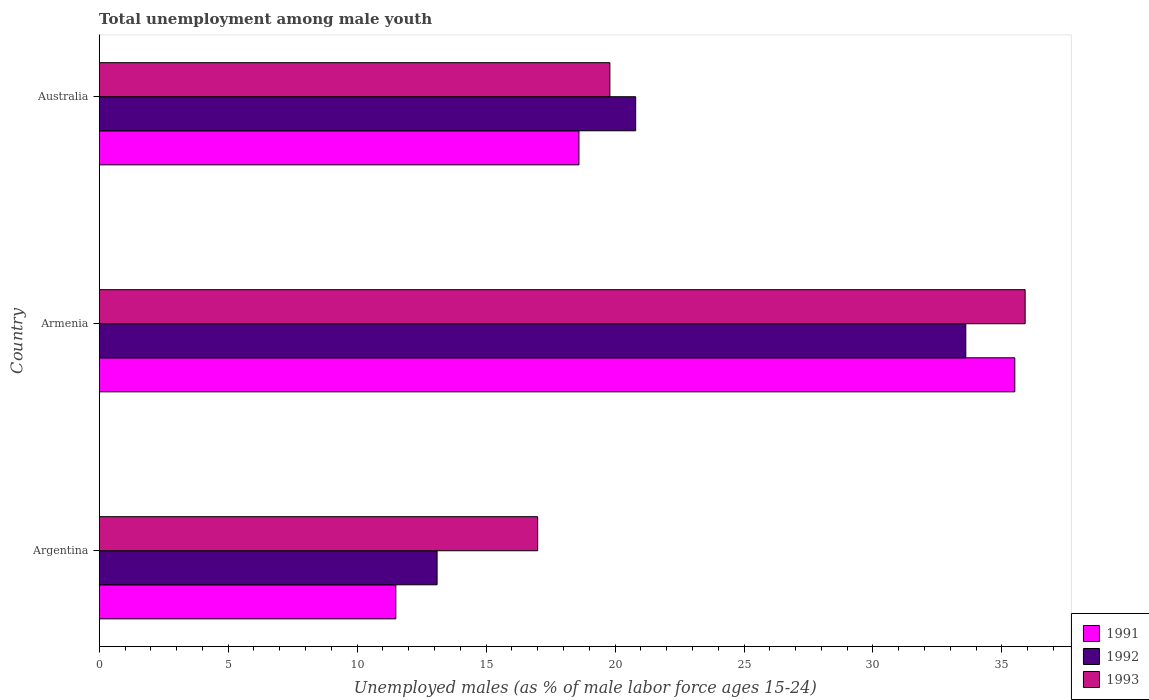Are the number of bars on each tick of the Y-axis equal?
Provide a succinct answer. Yes. What is the label of the 2nd group of bars from the top?
Your answer should be compact. Armenia. What is the percentage of unemployed males in in 1991 in Argentina?
Offer a terse response. 11.5. Across all countries, what is the maximum percentage of unemployed males in in 1991?
Provide a succinct answer. 35.5. Across all countries, what is the minimum percentage of unemployed males in in 1992?
Give a very brief answer. 13.1. In which country was the percentage of unemployed males in in 1992 maximum?
Give a very brief answer. Armenia. In which country was the percentage of unemployed males in in 1993 minimum?
Give a very brief answer. Argentina. What is the total percentage of unemployed males in in 1992 in the graph?
Provide a succinct answer. 67.5. What is the difference between the percentage of unemployed males in in 1992 in Argentina and that in Australia?
Your response must be concise. -7.7. What is the difference between the percentage of unemployed males in in 1993 in Argentina and the percentage of unemployed males in in 1992 in Armenia?
Your response must be concise. -16.6. What is the average percentage of unemployed males in in 1992 per country?
Provide a succinct answer. 22.5. What is the difference between the percentage of unemployed males in in 1992 and percentage of unemployed males in in 1991 in Armenia?
Give a very brief answer. -1.9. In how many countries, is the percentage of unemployed males in in 1993 greater than 11 %?
Provide a short and direct response. 3. What is the ratio of the percentage of unemployed males in in 1993 in Argentina to that in Armenia?
Offer a terse response. 0.47. Is the difference between the percentage of unemployed males in in 1992 in Argentina and Armenia greater than the difference between the percentage of unemployed males in in 1991 in Argentina and Armenia?
Keep it short and to the point. Yes. What is the difference between the highest and the second highest percentage of unemployed males in in 1993?
Provide a succinct answer. 16.1. What is the difference between the highest and the lowest percentage of unemployed males in in 1992?
Give a very brief answer. 20.5. Is the sum of the percentage of unemployed males in in 1992 in Armenia and Australia greater than the maximum percentage of unemployed males in in 1991 across all countries?
Give a very brief answer. Yes. What does the 2nd bar from the top in Australia represents?
Make the answer very short. 1992. What does the 3rd bar from the bottom in Argentina represents?
Offer a terse response. 1993. Are the values on the major ticks of X-axis written in scientific E-notation?
Offer a terse response. No. Does the graph contain any zero values?
Offer a terse response. No. Does the graph contain grids?
Give a very brief answer. No. Where does the legend appear in the graph?
Give a very brief answer. Bottom right. What is the title of the graph?
Make the answer very short. Total unemployment among male youth. Does "1997" appear as one of the legend labels in the graph?
Offer a terse response. No. What is the label or title of the X-axis?
Keep it short and to the point. Unemployed males (as % of male labor force ages 15-24). What is the label or title of the Y-axis?
Offer a very short reply. Country. What is the Unemployed males (as % of male labor force ages 15-24) of 1991 in Argentina?
Your response must be concise. 11.5. What is the Unemployed males (as % of male labor force ages 15-24) of 1992 in Argentina?
Provide a short and direct response. 13.1. What is the Unemployed males (as % of male labor force ages 15-24) in 1993 in Argentina?
Your answer should be compact. 17. What is the Unemployed males (as % of male labor force ages 15-24) of 1991 in Armenia?
Keep it short and to the point. 35.5. What is the Unemployed males (as % of male labor force ages 15-24) in 1992 in Armenia?
Your answer should be very brief. 33.6. What is the Unemployed males (as % of male labor force ages 15-24) in 1993 in Armenia?
Make the answer very short. 35.9. What is the Unemployed males (as % of male labor force ages 15-24) in 1991 in Australia?
Provide a succinct answer. 18.6. What is the Unemployed males (as % of male labor force ages 15-24) in 1992 in Australia?
Provide a succinct answer. 20.8. What is the Unemployed males (as % of male labor force ages 15-24) of 1993 in Australia?
Give a very brief answer. 19.8. Across all countries, what is the maximum Unemployed males (as % of male labor force ages 15-24) of 1991?
Give a very brief answer. 35.5. Across all countries, what is the maximum Unemployed males (as % of male labor force ages 15-24) in 1992?
Keep it short and to the point. 33.6. Across all countries, what is the maximum Unemployed males (as % of male labor force ages 15-24) of 1993?
Your answer should be very brief. 35.9. Across all countries, what is the minimum Unemployed males (as % of male labor force ages 15-24) in 1992?
Give a very brief answer. 13.1. Across all countries, what is the minimum Unemployed males (as % of male labor force ages 15-24) in 1993?
Ensure brevity in your answer.  17. What is the total Unemployed males (as % of male labor force ages 15-24) in 1991 in the graph?
Your answer should be very brief. 65.6. What is the total Unemployed males (as % of male labor force ages 15-24) of 1992 in the graph?
Keep it short and to the point. 67.5. What is the total Unemployed males (as % of male labor force ages 15-24) of 1993 in the graph?
Make the answer very short. 72.7. What is the difference between the Unemployed males (as % of male labor force ages 15-24) in 1992 in Argentina and that in Armenia?
Keep it short and to the point. -20.5. What is the difference between the Unemployed males (as % of male labor force ages 15-24) in 1993 in Argentina and that in Armenia?
Provide a short and direct response. -18.9. What is the difference between the Unemployed males (as % of male labor force ages 15-24) of 1992 in Argentina and that in Australia?
Your response must be concise. -7.7. What is the difference between the Unemployed males (as % of male labor force ages 15-24) in 1992 in Armenia and that in Australia?
Your response must be concise. 12.8. What is the difference between the Unemployed males (as % of male labor force ages 15-24) in 1991 in Argentina and the Unemployed males (as % of male labor force ages 15-24) in 1992 in Armenia?
Your response must be concise. -22.1. What is the difference between the Unemployed males (as % of male labor force ages 15-24) of 1991 in Argentina and the Unemployed males (as % of male labor force ages 15-24) of 1993 in Armenia?
Provide a succinct answer. -24.4. What is the difference between the Unemployed males (as % of male labor force ages 15-24) of 1992 in Argentina and the Unemployed males (as % of male labor force ages 15-24) of 1993 in Armenia?
Offer a terse response. -22.8. What is the difference between the Unemployed males (as % of male labor force ages 15-24) in 1991 in Armenia and the Unemployed males (as % of male labor force ages 15-24) in 1992 in Australia?
Your answer should be very brief. 14.7. What is the difference between the Unemployed males (as % of male labor force ages 15-24) in 1991 in Armenia and the Unemployed males (as % of male labor force ages 15-24) in 1993 in Australia?
Keep it short and to the point. 15.7. What is the difference between the Unemployed males (as % of male labor force ages 15-24) in 1992 in Armenia and the Unemployed males (as % of male labor force ages 15-24) in 1993 in Australia?
Give a very brief answer. 13.8. What is the average Unemployed males (as % of male labor force ages 15-24) in 1991 per country?
Offer a terse response. 21.87. What is the average Unemployed males (as % of male labor force ages 15-24) of 1993 per country?
Ensure brevity in your answer.  24.23. What is the difference between the Unemployed males (as % of male labor force ages 15-24) in 1991 and Unemployed males (as % of male labor force ages 15-24) in 1993 in Argentina?
Ensure brevity in your answer.  -5.5. What is the difference between the Unemployed males (as % of male labor force ages 15-24) of 1991 and Unemployed males (as % of male labor force ages 15-24) of 1992 in Australia?
Your answer should be very brief. -2.2. What is the ratio of the Unemployed males (as % of male labor force ages 15-24) of 1991 in Argentina to that in Armenia?
Ensure brevity in your answer.  0.32. What is the ratio of the Unemployed males (as % of male labor force ages 15-24) of 1992 in Argentina to that in Armenia?
Ensure brevity in your answer.  0.39. What is the ratio of the Unemployed males (as % of male labor force ages 15-24) of 1993 in Argentina to that in Armenia?
Provide a succinct answer. 0.47. What is the ratio of the Unemployed males (as % of male labor force ages 15-24) in 1991 in Argentina to that in Australia?
Your response must be concise. 0.62. What is the ratio of the Unemployed males (as % of male labor force ages 15-24) in 1992 in Argentina to that in Australia?
Your answer should be very brief. 0.63. What is the ratio of the Unemployed males (as % of male labor force ages 15-24) of 1993 in Argentina to that in Australia?
Ensure brevity in your answer.  0.86. What is the ratio of the Unemployed males (as % of male labor force ages 15-24) in 1991 in Armenia to that in Australia?
Provide a succinct answer. 1.91. What is the ratio of the Unemployed males (as % of male labor force ages 15-24) of 1992 in Armenia to that in Australia?
Your answer should be compact. 1.62. What is the ratio of the Unemployed males (as % of male labor force ages 15-24) in 1993 in Armenia to that in Australia?
Offer a very short reply. 1.81. What is the difference between the highest and the second highest Unemployed males (as % of male labor force ages 15-24) of 1992?
Offer a very short reply. 12.8. What is the difference between the highest and the lowest Unemployed males (as % of male labor force ages 15-24) in 1991?
Make the answer very short. 24. What is the difference between the highest and the lowest Unemployed males (as % of male labor force ages 15-24) of 1992?
Keep it short and to the point. 20.5. 